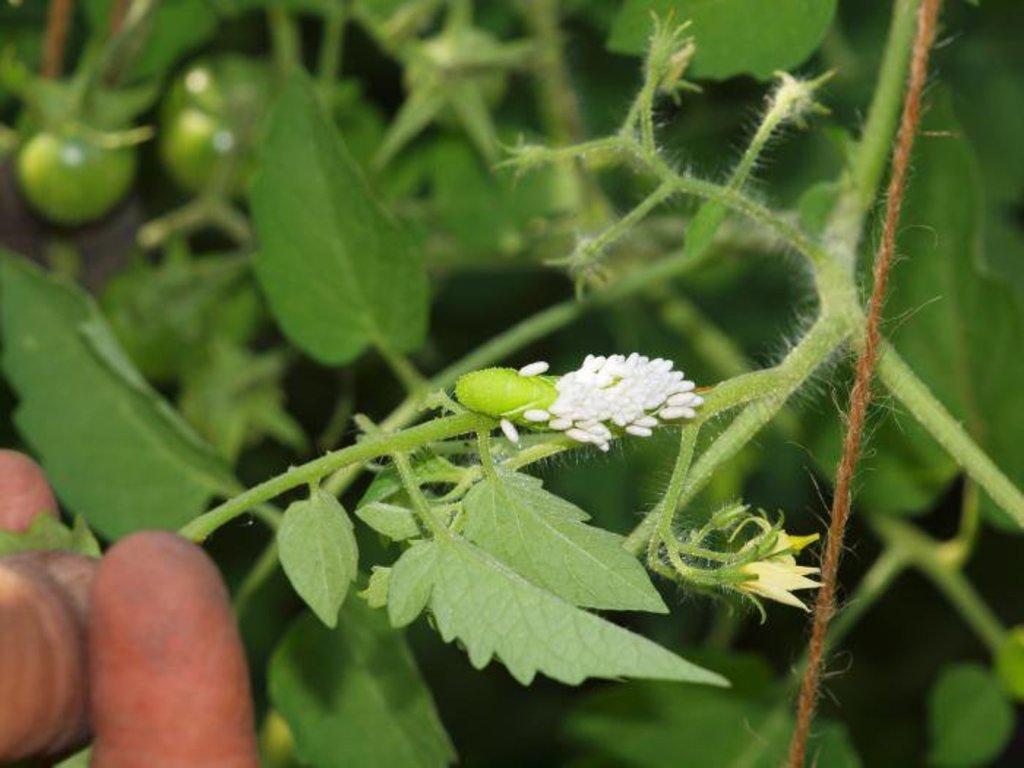Can you describe this image briefly? Here we can see a plant and rope. Background it is blur. 